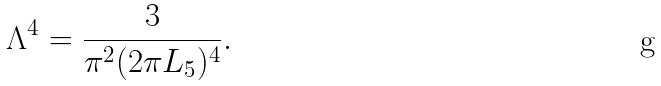Convert formula to latex. <formula><loc_0><loc_0><loc_500><loc_500>\Lambda ^ { 4 } = \frac { 3 } { \pi ^ { 2 } ( 2 \pi L _ { 5 } ) ^ { 4 } } .</formula> 